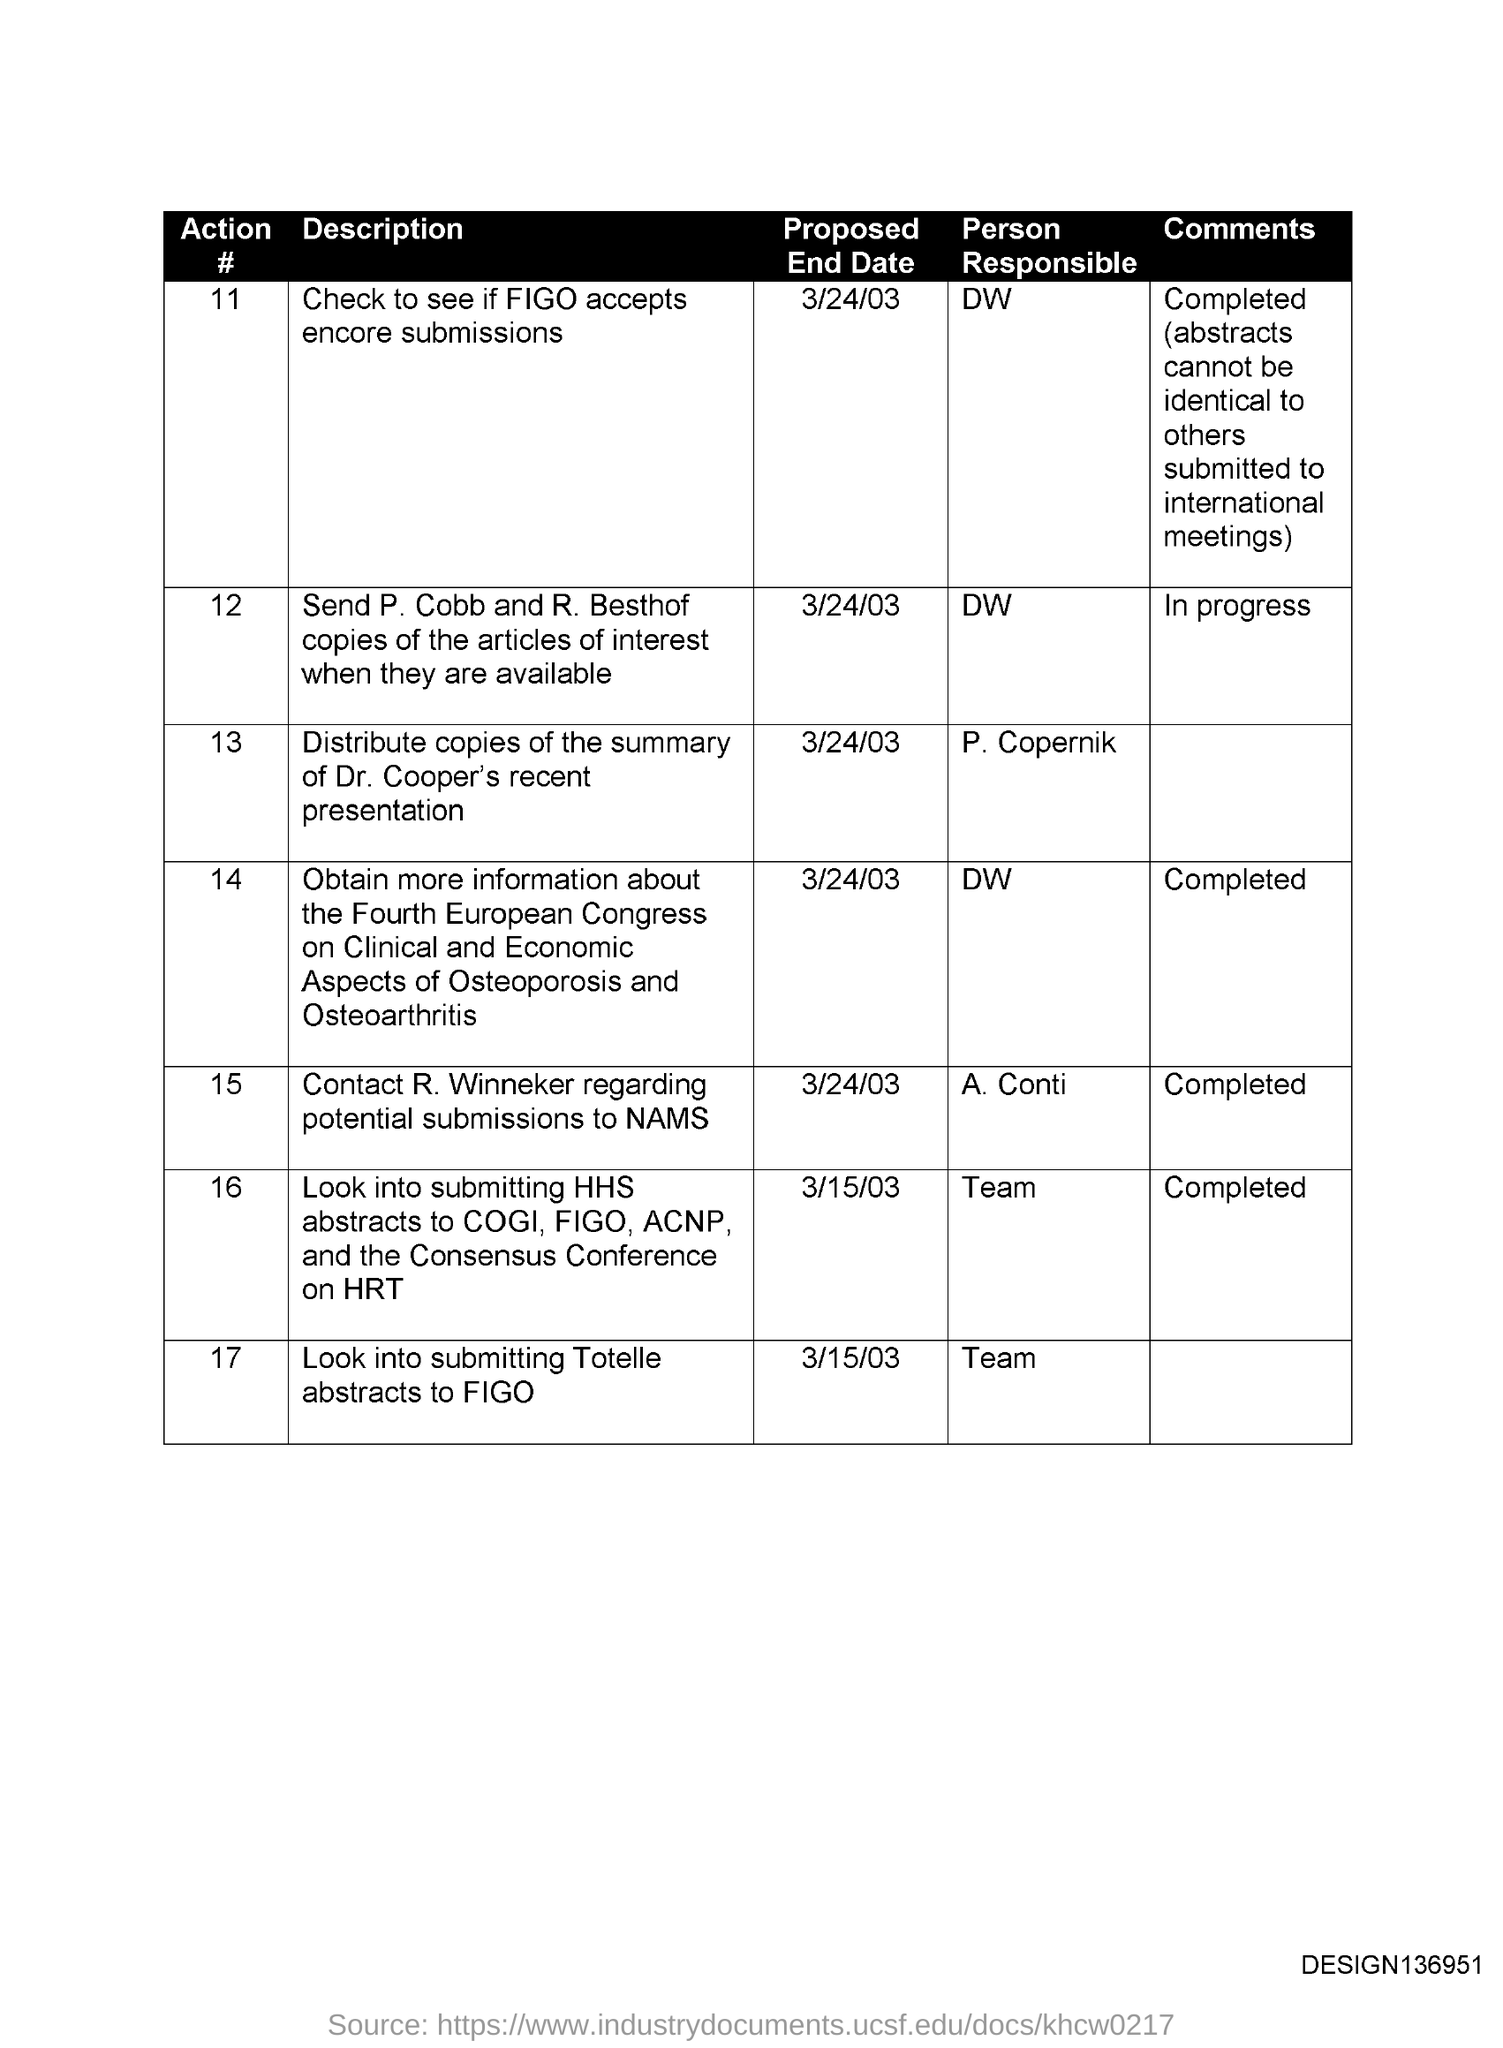What is comments written against Action # No. 12?
Your response must be concise. In Progress. What is comments written against Action # No. 14?
Offer a terse response. Completed. Who is responsible for Action # No. 11?
Keep it short and to the point. DW. Who is responsible for action # 17
Offer a very short reply. Team. 